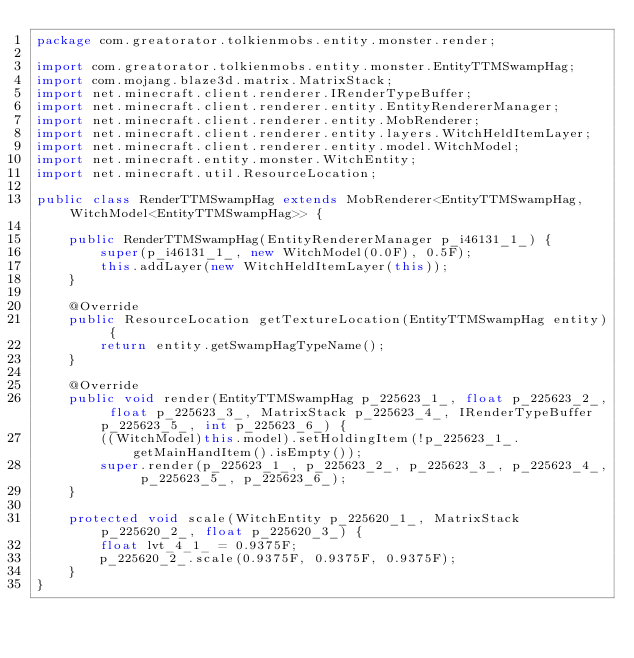Convert code to text. <code><loc_0><loc_0><loc_500><loc_500><_Java_>package com.greatorator.tolkienmobs.entity.monster.render;

import com.greatorator.tolkienmobs.entity.monster.EntityTTMSwampHag;
import com.mojang.blaze3d.matrix.MatrixStack;
import net.minecraft.client.renderer.IRenderTypeBuffer;
import net.minecraft.client.renderer.entity.EntityRendererManager;
import net.minecraft.client.renderer.entity.MobRenderer;
import net.minecraft.client.renderer.entity.layers.WitchHeldItemLayer;
import net.minecraft.client.renderer.entity.model.WitchModel;
import net.minecraft.entity.monster.WitchEntity;
import net.minecraft.util.ResourceLocation;

public class RenderTTMSwampHag extends MobRenderer<EntityTTMSwampHag, WitchModel<EntityTTMSwampHag>> {

    public RenderTTMSwampHag(EntityRendererManager p_i46131_1_) {
        super(p_i46131_1_, new WitchModel(0.0F), 0.5F);
        this.addLayer(new WitchHeldItemLayer(this));
    }

    @Override
    public ResourceLocation getTextureLocation(EntityTTMSwampHag entity) {
        return entity.getSwampHagTypeName();
    }

    @Override
    public void render(EntityTTMSwampHag p_225623_1_, float p_225623_2_, float p_225623_3_, MatrixStack p_225623_4_, IRenderTypeBuffer p_225623_5_, int p_225623_6_) {
        ((WitchModel)this.model).setHoldingItem(!p_225623_1_.getMainHandItem().isEmpty());
        super.render(p_225623_1_, p_225623_2_, p_225623_3_, p_225623_4_, p_225623_5_, p_225623_6_);
    }

    protected void scale(WitchEntity p_225620_1_, MatrixStack p_225620_2_, float p_225620_3_) {
        float lvt_4_1_ = 0.9375F;
        p_225620_2_.scale(0.9375F, 0.9375F, 0.9375F);
    }
}</code> 